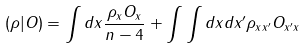<formula> <loc_0><loc_0><loc_500><loc_500>( \rho | O ) = \int d x \frac { \rho _ { x } O _ { x } } { n - 4 } + \int \int d x d x ^ { \prime } \rho _ { x x ^ { \prime } } O _ { x ^ { \prime } x }</formula> 